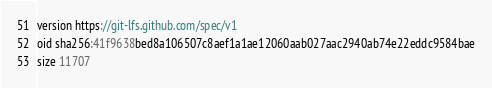Convert code to text. <code><loc_0><loc_0><loc_500><loc_500><_C_>version https://git-lfs.github.com/spec/v1
oid sha256:41f9638bed8a106507c8aef1a1ae12060aab027aac2940ab74e22eddc9584bae
size 11707
</code> 